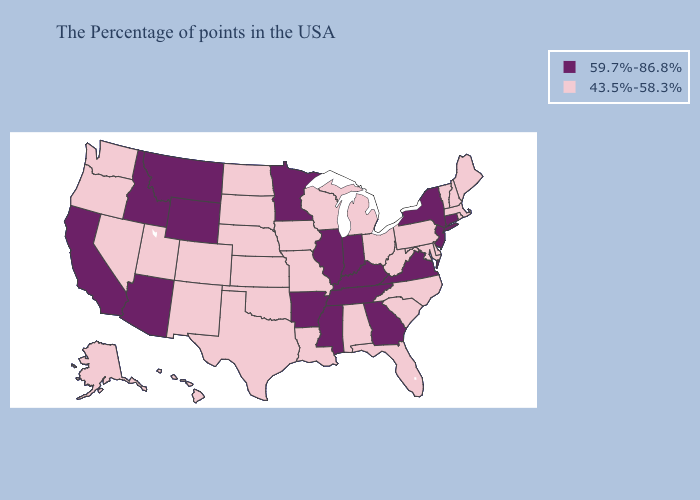Name the states that have a value in the range 59.7%-86.8%?
Concise answer only. Connecticut, New York, New Jersey, Virginia, Georgia, Kentucky, Indiana, Tennessee, Illinois, Mississippi, Arkansas, Minnesota, Wyoming, Montana, Arizona, Idaho, California. Does Virginia have the lowest value in the USA?
Quick response, please. No. Among the states that border Mississippi , does Tennessee have the highest value?
Answer briefly. Yes. Name the states that have a value in the range 59.7%-86.8%?
Write a very short answer. Connecticut, New York, New Jersey, Virginia, Georgia, Kentucky, Indiana, Tennessee, Illinois, Mississippi, Arkansas, Minnesota, Wyoming, Montana, Arizona, Idaho, California. What is the value of Nevada?
Keep it brief. 43.5%-58.3%. What is the highest value in the MidWest ?
Quick response, please. 59.7%-86.8%. Among the states that border Indiana , which have the lowest value?
Give a very brief answer. Ohio, Michigan. Which states have the lowest value in the USA?
Keep it brief. Maine, Massachusetts, Rhode Island, New Hampshire, Vermont, Delaware, Maryland, Pennsylvania, North Carolina, South Carolina, West Virginia, Ohio, Florida, Michigan, Alabama, Wisconsin, Louisiana, Missouri, Iowa, Kansas, Nebraska, Oklahoma, Texas, South Dakota, North Dakota, Colorado, New Mexico, Utah, Nevada, Washington, Oregon, Alaska, Hawaii. What is the value of Nebraska?
Keep it brief. 43.5%-58.3%. What is the value of Tennessee?
Be succinct. 59.7%-86.8%. Which states hav the highest value in the MidWest?
Short answer required. Indiana, Illinois, Minnesota. Which states have the lowest value in the USA?
Give a very brief answer. Maine, Massachusetts, Rhode Island, New Hampshire, Vermont, Delaware, Maryland, Pennsylvania, North Carolina, South Carolina, West Virginia, Ohio, Florida, Michigan, Alabama, Wisconsin, Louisiana, Missouri, Iowa, Kansas, Nebraska, Oklahoma, Texas, South Dakota, North Dakota, Colorado, New Mexico, Utah, Nevada, Washington, Oregon, Alaska, Hawaii. What is the value of Maine?
Short answer required. 43.5%-58.3%. What is the value of Minnesota?
Concise answer only. 59.7%-86.8%. Which states have the highest value in the USA?
Give a very brief answer. Connecticut, New York, New Jersey, Virginia, Georgia, Kentucky, Indiana, Tennessee, Illinois, Mississippi, Arkansas, Minnesota, Wyoming, Montana, Arizona, Idaho, California. 